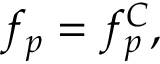<formula> <loc_0><loc_0><loc_500><loc_500>f _ { p } = f _ { p } ^ { C } ,</formula> 